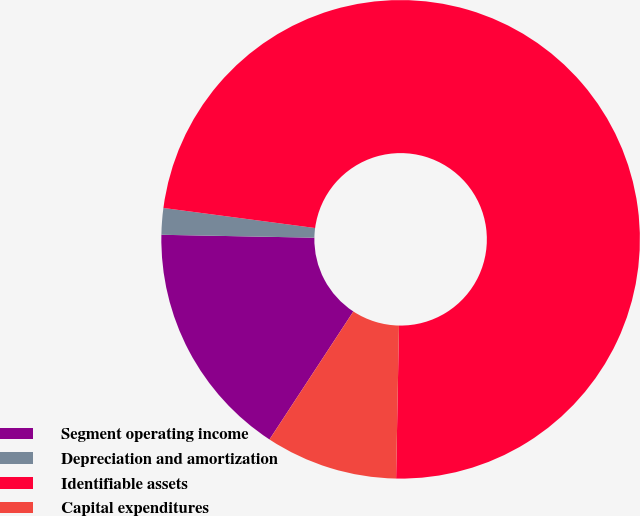Convert chart. <chart><loc_0><loc_0><loc_500><loc_500><pie_chart><fcel>Segment operating income<fcel>Depreciation and amortization<fcel>Identifiable assets<fcel>Capital expenditures<nl><fcel>16.07%<fcel>1.79%<fcel>73.2%<fcel>8.93%<nl></chart> 